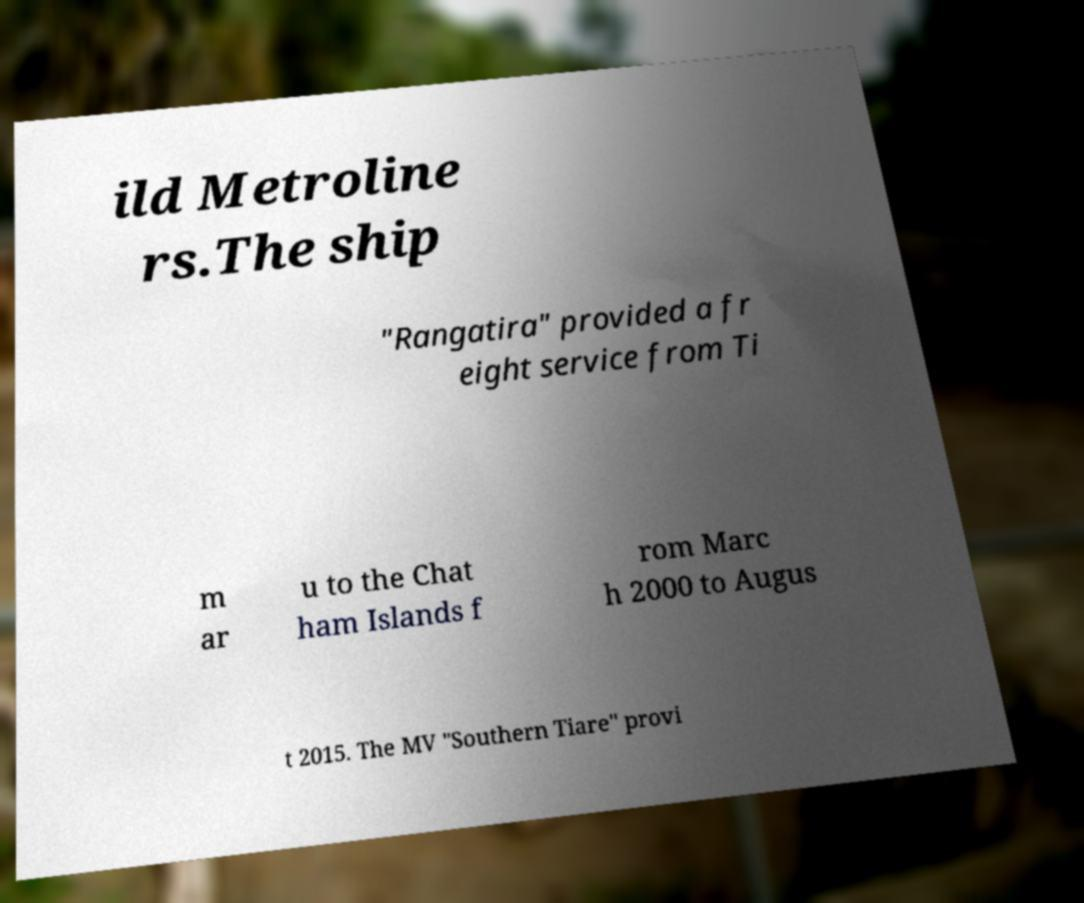Can you accurately transcribe the text from the provided image for me? ild Metroline rs.The ship "Rangatira" provided a fr eight service from Ti m ar u to the Chat ham Islands f rom Marc h 2000 to Augus t 2015. The MV "Southern Tiare" provi 